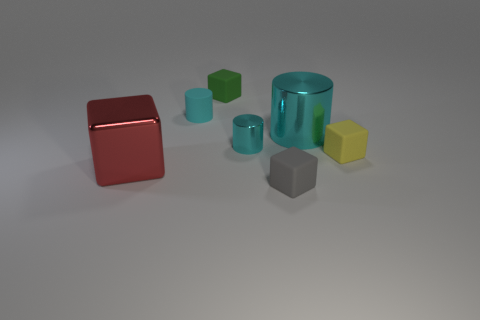Subtract all cyan cylinders. How many were subtracted if there are1cyan cylinders left? 2 Subtract 2 cylinders. How many cylinders are left? 1 Subtract all brown cubes. Subtract all green balls. How many cubes are left? 4 Add 1 small metallic cylinders. How many objects exist? 8 Subtract all blocks. How many objects are left? 3 Add 3 tiny cyan metallic cylinders. How many tiny cyan metallic cylinders exist? 4 Subtract 0 cyan blocks. How many objects are left? 7 Subtract all tiny green things. Subtract all gray matte things. How many objects are left? 5 Add 6 green objects. How many green objects are left? 7 